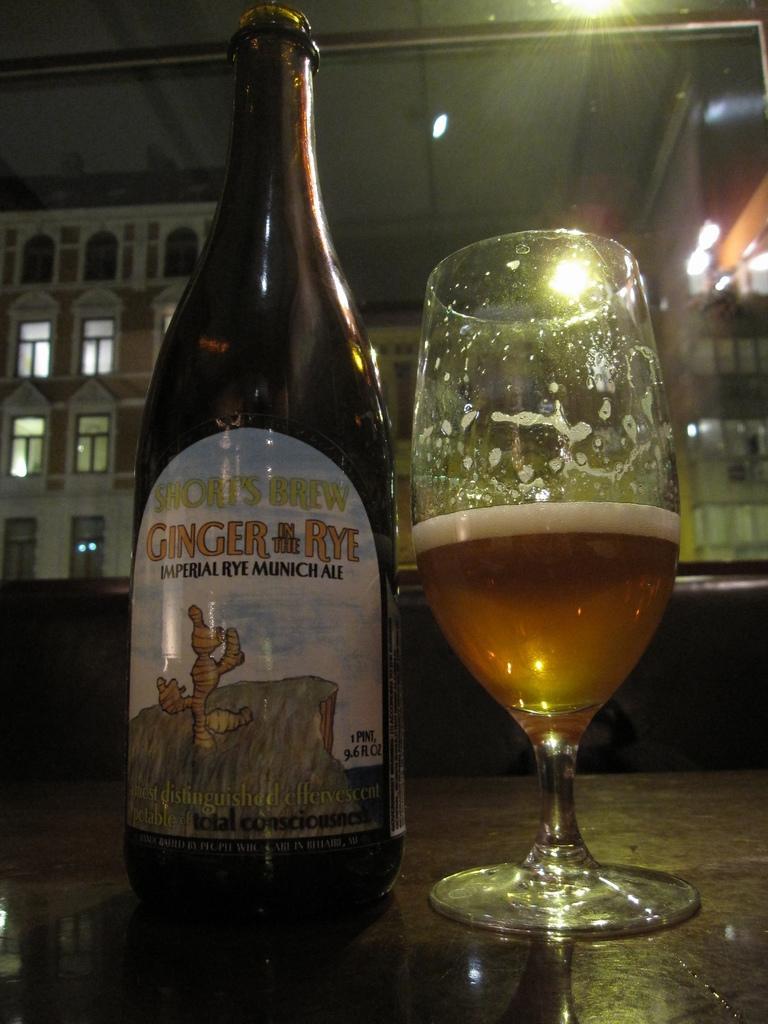Can you describe this image briefly? This picture shows a bottle and a wine glass on the table and we see couple of buildings 